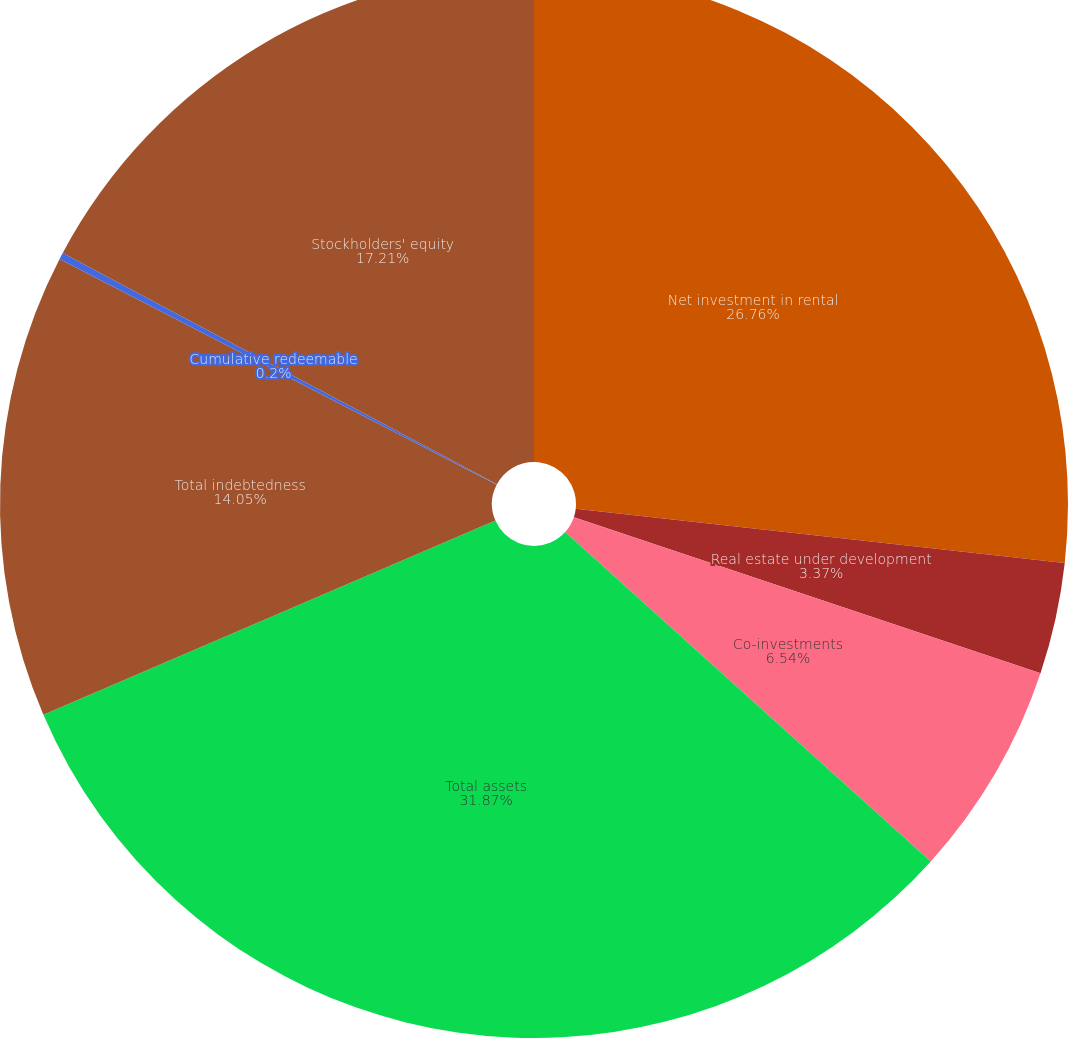<chart> <loc_0><loc_0><loc_500><loc_500><pie_chart><fcel>Net investment in rental<fcel>Real estate under development<fcel>Co-investments<fcel>Total assets<fcel>Total indebtedness<fcel>Cumulative redeemable<fcel>Stockholders' equity<nl><fcel>26.76%<fcel>3.37%<fcel>6.54%<fcel>31.87%<fcel>14.05%<fcel>0.2%<fcel>17.21%<nl></chart> 